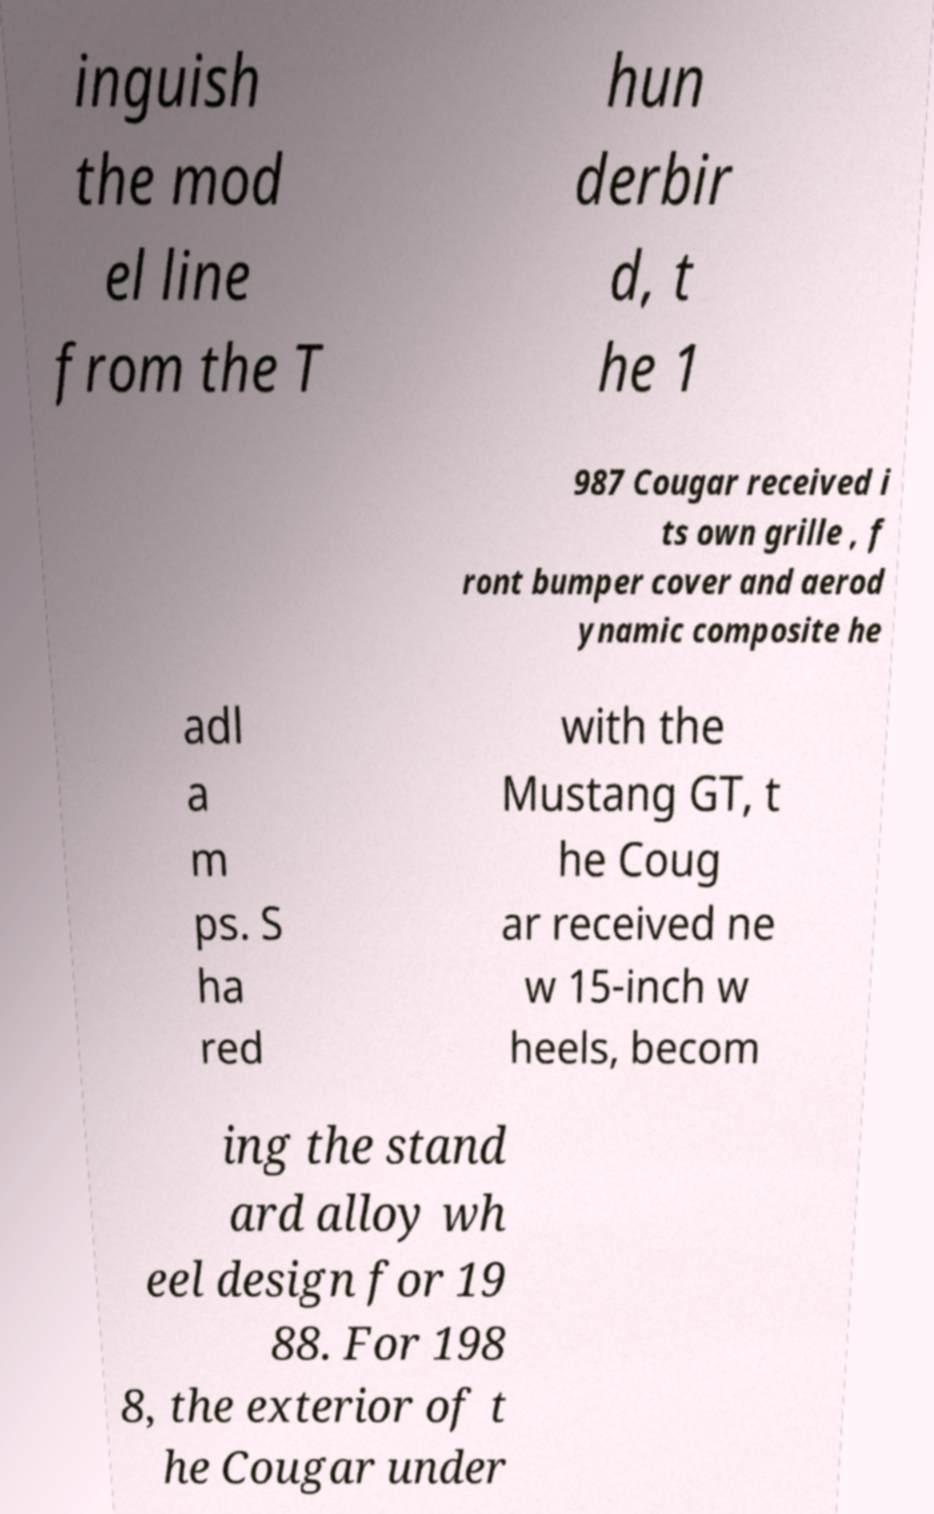There's text embedded in this image that I need extracted. Can you transcribe it verbatim? inguish the mod el line from the T hun derbir d, t he 1 987 Cougar received i ts own grille , f ront bumper cover and aerod ynamic composite he adl a m ps. S ha red with the Mustang GT, t he Coug ar received ne w 15-inch w heels, becom ing the stand ard alloy wh eel design for 19 88. For 198 8, the exterior of t he Cougar under 